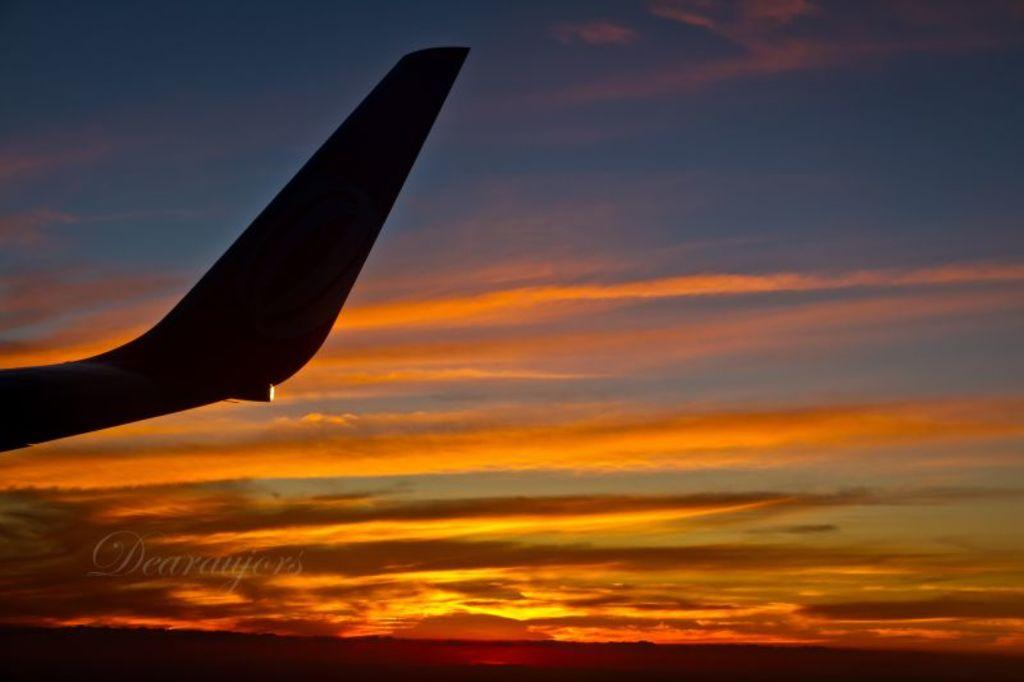<image>
Offer a succinct explanation of the picture presented. A plane tail with a sunset background with the water mark Dearaujes. 